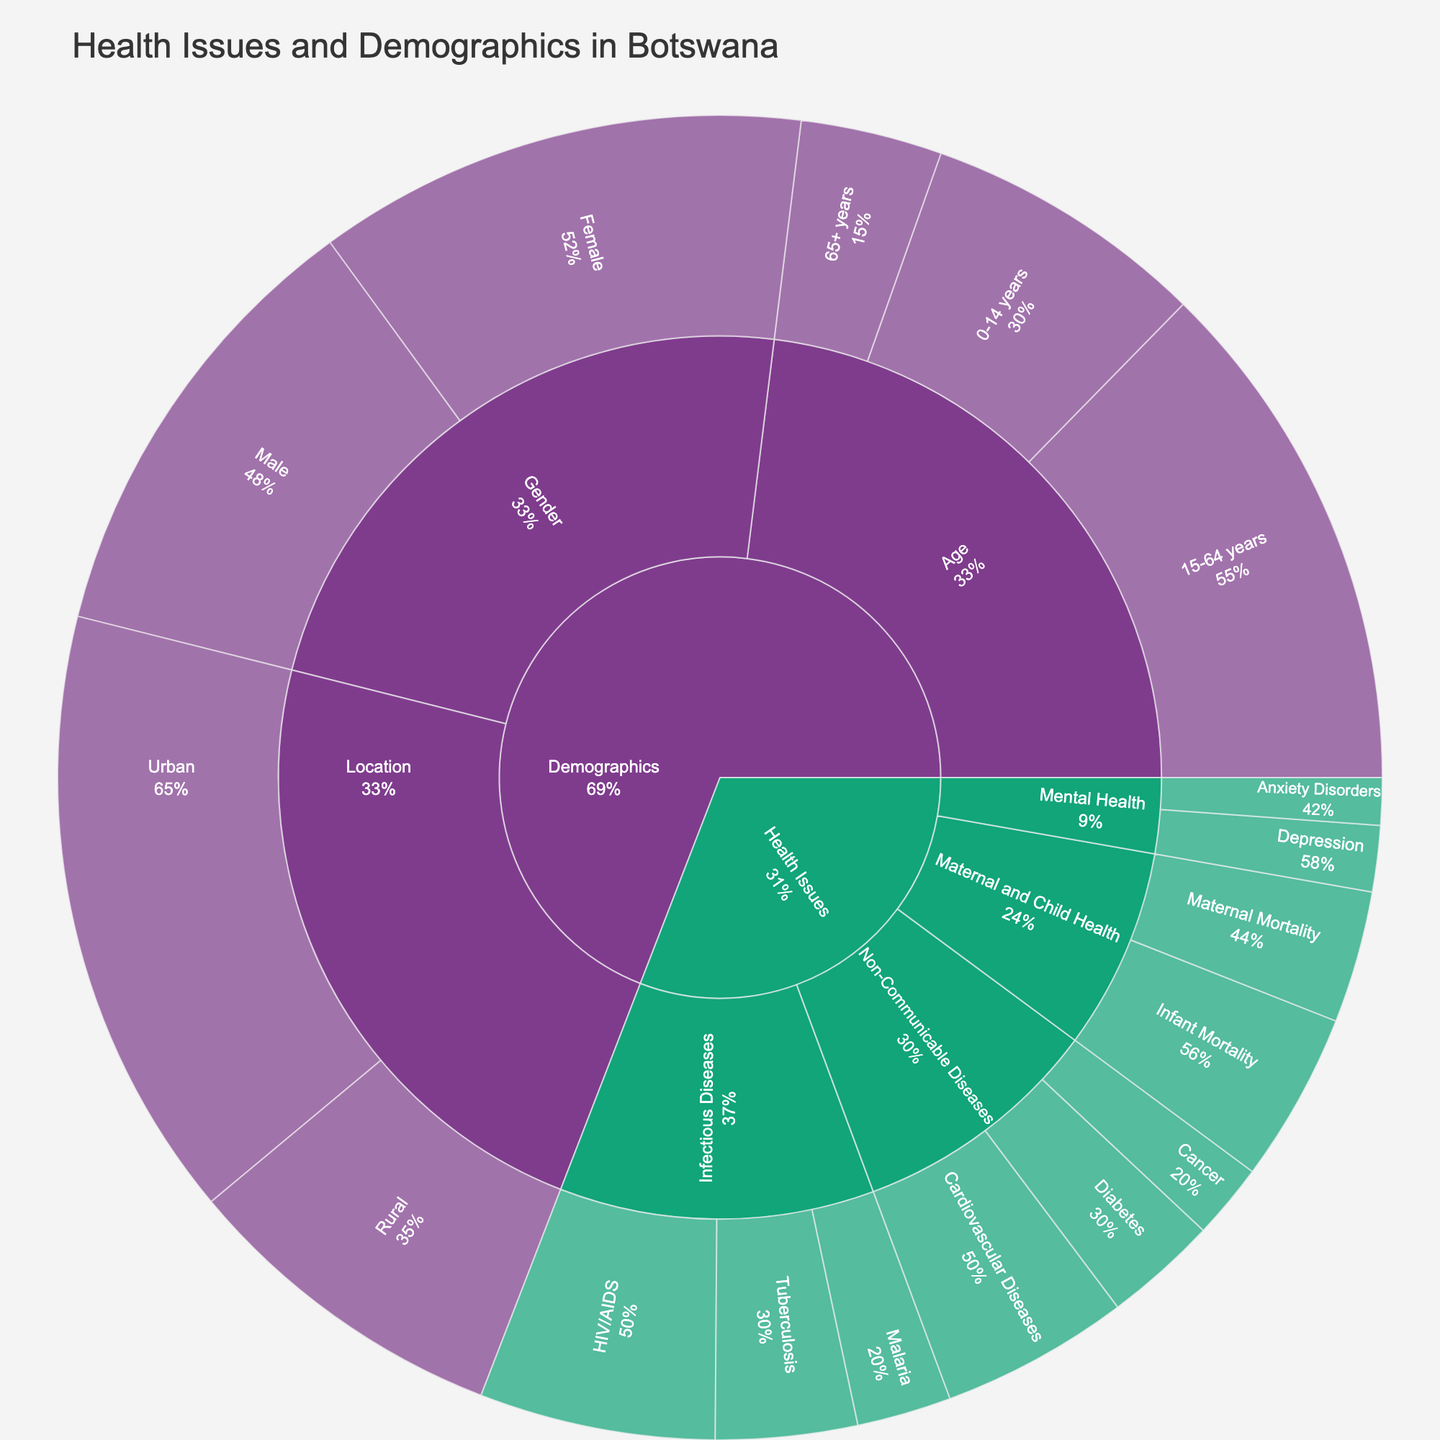What is the most common health issue represented in the plot? By looking at the colors and sections in the Sunburst Plot, we can see which health issue has the largest section.
Answer: HIV/AIDS How does the value of HIV/AIDS compare to Tuberculosis? The plot indicates that HIV/AIDS has a value of 25, while Tuberculosis has a value of 15. Subtracting these values, we get 25 - 15 = 10.
Answer: HIV/AIDS value is 10 higher than Tuberculosis Which demographic category, 'Location' or 'Age', has a higher combined value? By summing the values for each demographic subcategory, 'Location' has values of 65 (Urban) and 35 (Rural), so 65 + 35 = 100. 'Age' has values of 30 (0-14 years), 55 (15-64 years), and 15 (65+ years), so 30 + 55 + 15 = 100. Both categories are equal.
Answer: Both are 100 What percentage of 'Non-Communicable Diseases' is represented by 'Diabetes'? The total value for 'Non-Communicable Diseases' is 20 (Cardiovascular Diseases) + 12 (Diabetes) + 8 (Cancer) = 40. The percentage of Diabetes is (12 / 40) * 100%.
Answer: 30% Which gender has a higher value in the 'Demographics' section? From the plot, Male has a value of 48, and Female has a value of 52. Comparing these, Female has a higher value.
Answer: Female Compare the values of 'Urban' and 'Rural' populations. How many more people live in urban areas than in rural areas? The plot shows Urban has a value of 65 and Rural has a value of 35. The difference is 65 - 35 = 30.
Answer: 30 more people live in urban areas What is the total value for 'Infectious Diseases'? Summing up the values of HIV/AIDS (25), Tuberculosis (15), and Malaria (10), we get 25 + 15 + 10 = 50.
Answer: 50 What is the least common mental health issue represented in the plot? The smallest segment under Mental Health shows Anxiety Disorders with a value of 5, making it the least common.
Answer: Anxiety Disorders How many more people are there in the 15-64 years age group compared to the 0-14 years age group? The values are 55 for 15-64 years and 30 for 0-14 years age groups. The difference is 55 - 30 = 25.
Answer: 25 more people What is the percentage of the 'Demographics' section represented by the 'Gender' subcategory? The total value for 'Demographics' is 30 (0-14) + 55 (15-64) + 15 (65+ years) + 48 (Male) + 52 (Female) + 65 (Urban) + 35 (Rural) = 300. The value for 'Gender' is 48 (Male) + 52 (Female) = 100. The percentage of 'Gender' in 'Demographics' is (100 / 300) * 100%
Answer: 33.3% 